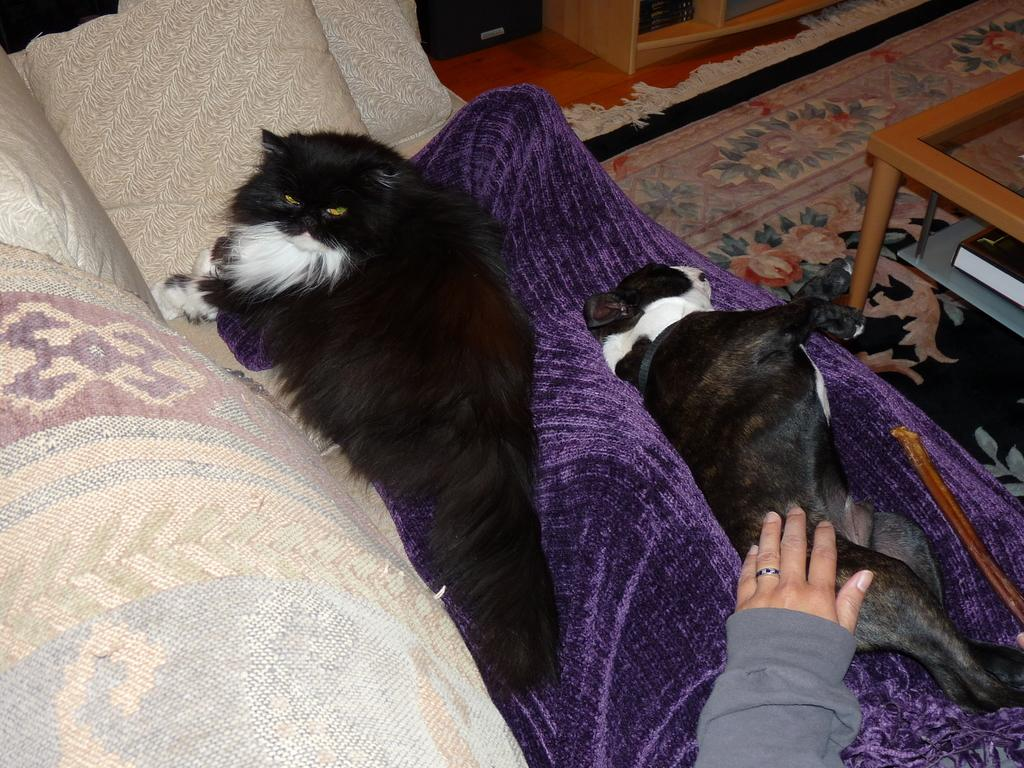What is the person doing on the couch in the image? The person is lying on the couch in the image. What other animals are present on the couch? There is a cat and a dog lying on the couch in the image. What type of flooring is visible in the image? The floor has a carpet in the image. What furniture is present in the image besides the couch? There is a table in the image. What object is located under the table? There is a book under the table in the image. How many eggs are visible on the couch in the image? There are no eggs visible on the couch in the image. What type of dinosaur can be seen walking in the background of the image? There are no dinosaurs present in the image; it features a person, cat, and dog lying on a couch. 